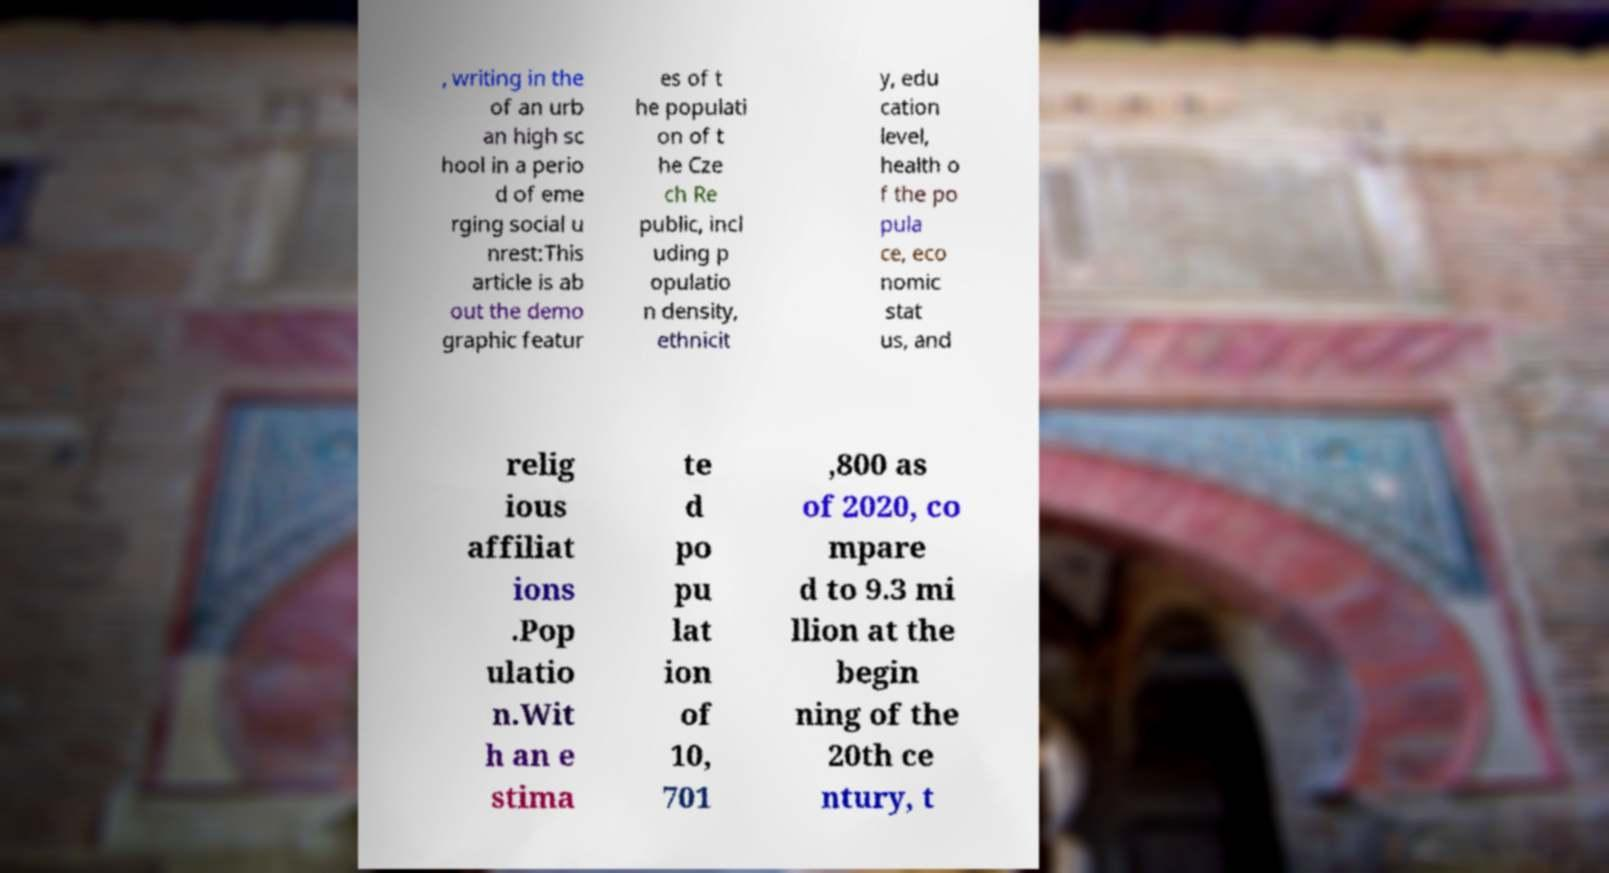There's text embedded in this image that I need extracted. Can you transcribe it verbatim? , writing in the of an urb an high sc hool in a perio d of eme rging social u nrest:This article is ab out the demo graphic featur es of t he populati on of t he Cze ch Re public, incl uding p opulatio n density, ethnicit y, edu cation level, health o f the po pula ce, eco nomic stat us, and relig ious affiliat ions .Pop ulatio n.Wit h an e stima te d po pu lat ion of 10, 701 ,800 as of 2020, co mpare d to 9.3 mi llion at the begin ning of the 20th ce ntury, t 